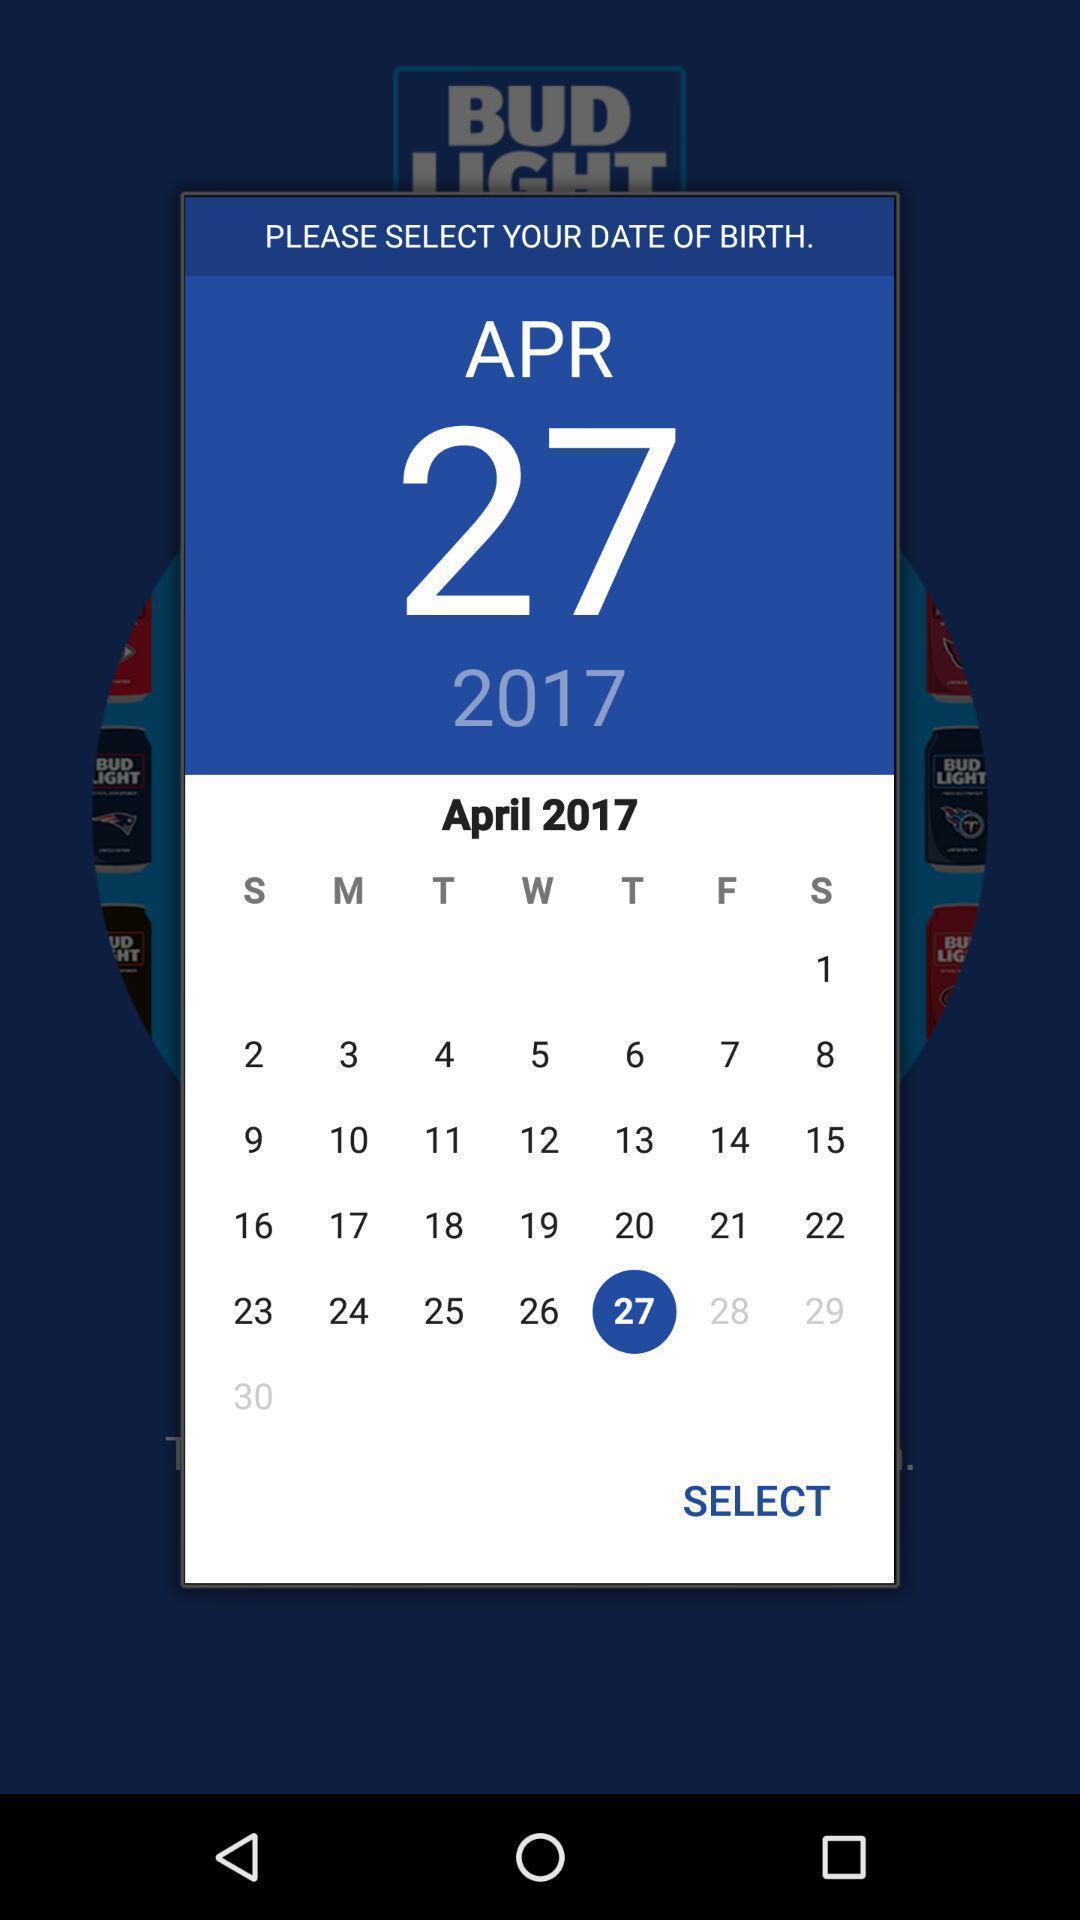Provide a textual representation of this image. Pop-up shows calendar. 